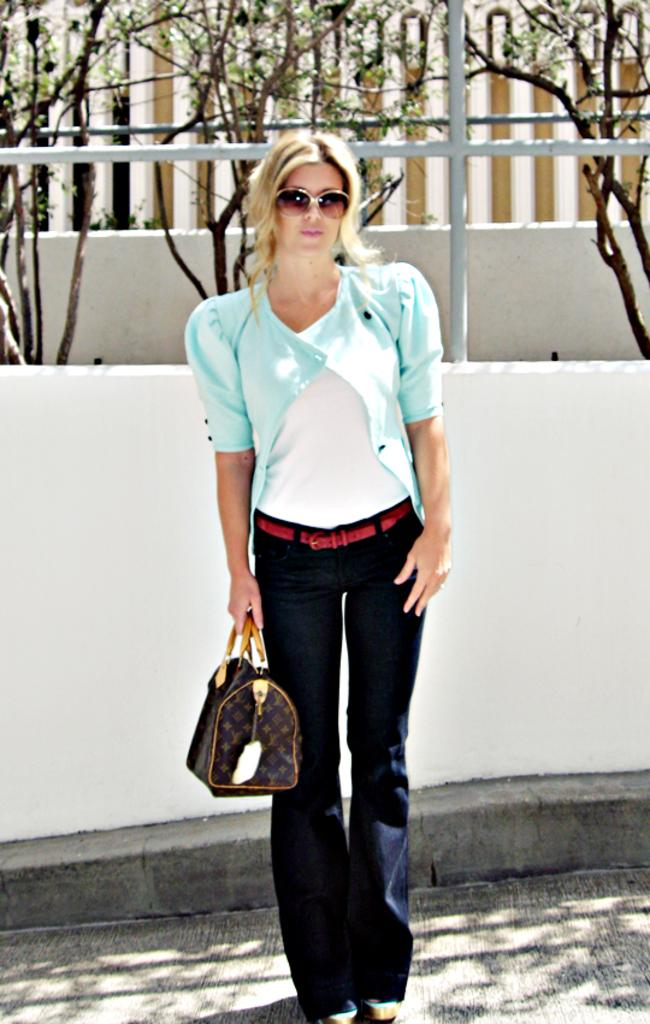What is the main subject of the image? The main subject of the image is a woman. What is the woman wearing on her face? The woman is wearing goggles. What color is the jacket the woman is wearing? The woman is wearing a sky blue jacket. What is the woman holding in the image? The woman is holding a bag. What can be seen in the background of the image? There are trees in the background of the image. What type of heart-shaped object can be seen in the image? There is no heart-shaped object present in the image. What type of beam is being used by the woman in the image? There is no beam being used by the woman in the image. 